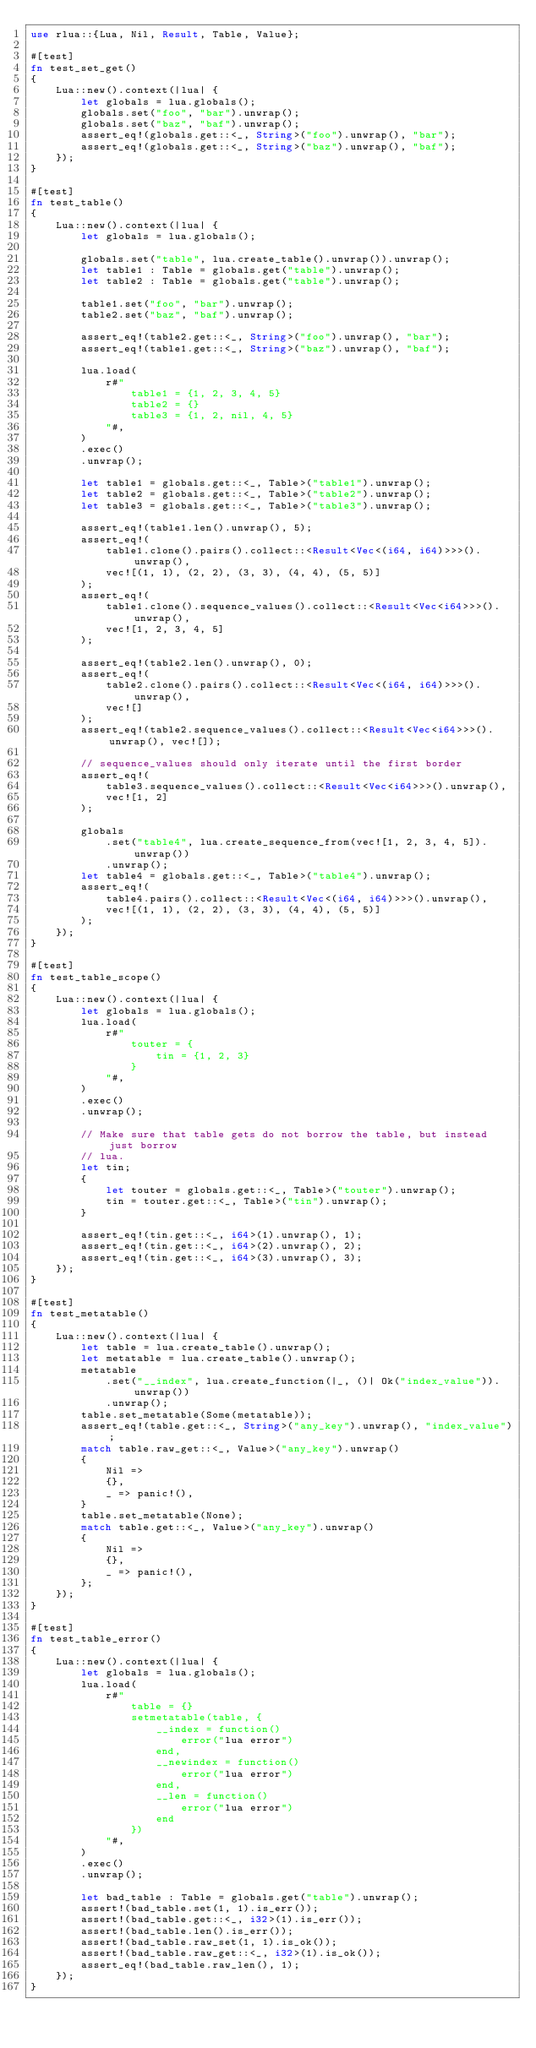<code> <loc_0><loc_0><loc_500><loc_500><_Rust_>use rlua::{Lua, Nil, Result, Table, Value};

#[test]
fn test_set_get()
{
    Lua::new().context(|lua| {
        let globals = lua.globals();
        globals.set("foo", "bar").unwrap();
        globals.set("baz", "baf").unwrap();
        assert_eq!(globals.get::<_, String>("foo").unwrap(), "bar");
        assert_eq!(globals.get::<_, String>("baz").unwrap(), "baf");
    });
}

#[test]
fn test_table()
{
    Lua::new().context(|lua| {
        let globals = lua.globals();

        globals.set("table", lua.create_table().unwrap()).unwrap();
        let table1 : Table = globals.get("table").unwrap();
        let table2 : Table = globals.get("table").unwrap();

        table1.set("foo", "bar").unwrap();
        table2.set("baz", "baf").unwrap();

        assert_eq!(table2.get::<_, String>("foo").unwrap(), "bar");
        assert_eq!(table1.get::<_, String>("baz").unwrap(), "baf");

        lua.load(
            r#"
                table1 = {1, 2, 3, 4, 5}
                table2 = {}
                table3 = {1, 2, nil, 4, 5}
            "#,
        )
        .exec()
        .unwrap();

        let table1 = globals.get::<_, Table>("table1").unwrap();
        let table2 = globals.get::<_, Table>("table2").unwrap();
        let table3 = globals.get::<_, Table>("table3").unwrap();

        assert_eq!(table1.len().unwrap(), 5);
        assert_eq!(
            table1.clone().pairs().collect::<Result<Vec<(i64, i64)>>>().unwrap(),
            vec![(1, 1), (2, 2), (3, 3), (4, 4), (5, 5)]
        );
        assert_eq!(
            table1.clone().sequence_values().collect::<Result<Vec<i64>>>().unwrap(),
            vec![1, 2, 3, 4, 5]
        );

        assert_eq!(table2.len().unwrap(), 0);
        assert_eq!(
            table2.clone().pairs().collect::<Result<Vec<(i64, i64)>>>().unwrap(),
            vec![]
        );
        assert_eq!(table2.sequence_values().collect::<Result<Vec<i64>>>().unwrap(), vec![]);

        // sequence_values should only iterate until the first border
        assert_eq!(
            table3.sequence_values().collect::<Result<Vec<i64>>>().unwrap(),
            vec![1, 2]
        );

        globals
            .set("table4", lua.create_sequence_from(vec![1, 2, 3, 4, 5]).unwrap())
            .unwrap();
        let table4 = globals.get::<_, Table>("table4").unwrap();
        assert_eq!(
            table4.pairs().collect::<Result<Vec<(i64, i64)>>>().unwrap(),
            vec![(1, 1), (2, 2), (3, 3), (4, 4), (5, 5)]
        );
    });
}

#[test]
fn test_table_scope()
{
    Lua::new().context(|lua| {
        let globals = lua.globals();
        lua.load(
            r#"
                touter = {
                    tin = {1, 2, 3}
                }
            "#,
        )
        .exec()
        .unwrap();

        // Make sure that table gets do not borrow the table, but instead just borrow
        // lua.
        let tin;
        {
            let touter = globals.get::<_, Table>("touter").unwrap();
            tin = touter.get::<_, Table>("tin").unwrap();
        }

        assert_eq!(tin.get::<_, i64>(1).unwrap(), 1);
        assert_eq!(tin.get::<_, i64>(2).unwrap(), 2);
        assert_eq!(tin.get::<_, i64>(3).unwrap(), 3);
    });
}

#[test]
fn test_metatable()
{
    Lua::new().context(|lua| {
        let table = lua.create_table().unwrap();
        let metatable = lua.create_table().unwrap();
        metatable
            .set("__index", lua.create_function(|_, ()| Ok("index_value")).unwrap())
            .unwrap();
        table.set_metatable(Some(metatable));
        assert_eq!(table.get::<_, String>("any_key").unwrap(), "index_value");
        match table.raw_get::<_, Value>("any_key").unwrap()
        {
            Nil =>
            {},
            _ => panic!(),
        }
        table.set_metatable(None);
        match table.get::<_, Value>("any_key").unwrap()
        {
            Nil =>
            {},
            _ => panic!(),
        };
    });
}

#[test]
fn test_table_error()
{
    Lua::new().context(|lua| {
        let globals = lua.globals();
        lua.load(
            r#"
                table = {}
                setmetatable(table, {
                    __index = function()
                        error("lua error")
                    end,
                    __newindex = function()
                        error("lua error")
                    end,
                    __len = function()
                        error("lua error")
                    end
                })
            "#,
        )
        .exec()
        .unwrap();

        let bad_table : Table = globals.get("table").unwrap();
        assert!(bad_table.set(1, 1).is_err());
        assert!(bad_table.get::<_, i32>(1).is_err());
        assert!(bad_table.len().is_err());
        assert!(bad_table.raw_set(1, 1).is_ok());
        assert!(bad_table.raw_get::<_, i32>(1).is_ok());
        assert_eq!(bad_table.raw_len(), 1);
    });
}
</code> 